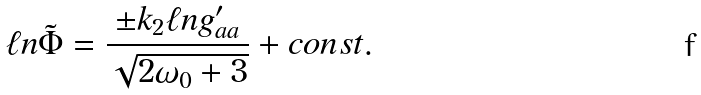Convert formula to latex. <formula><loc_0><loc_0><loc_500><loc_500>\ell n \tilde { \Phi } = \frac { \pm k _ { 2 } \ell n g ^ { \prime } _ { a a } } { \sqrt { 2 \omega _ { 0 } + 3 } } + c o n s t .</formula> 